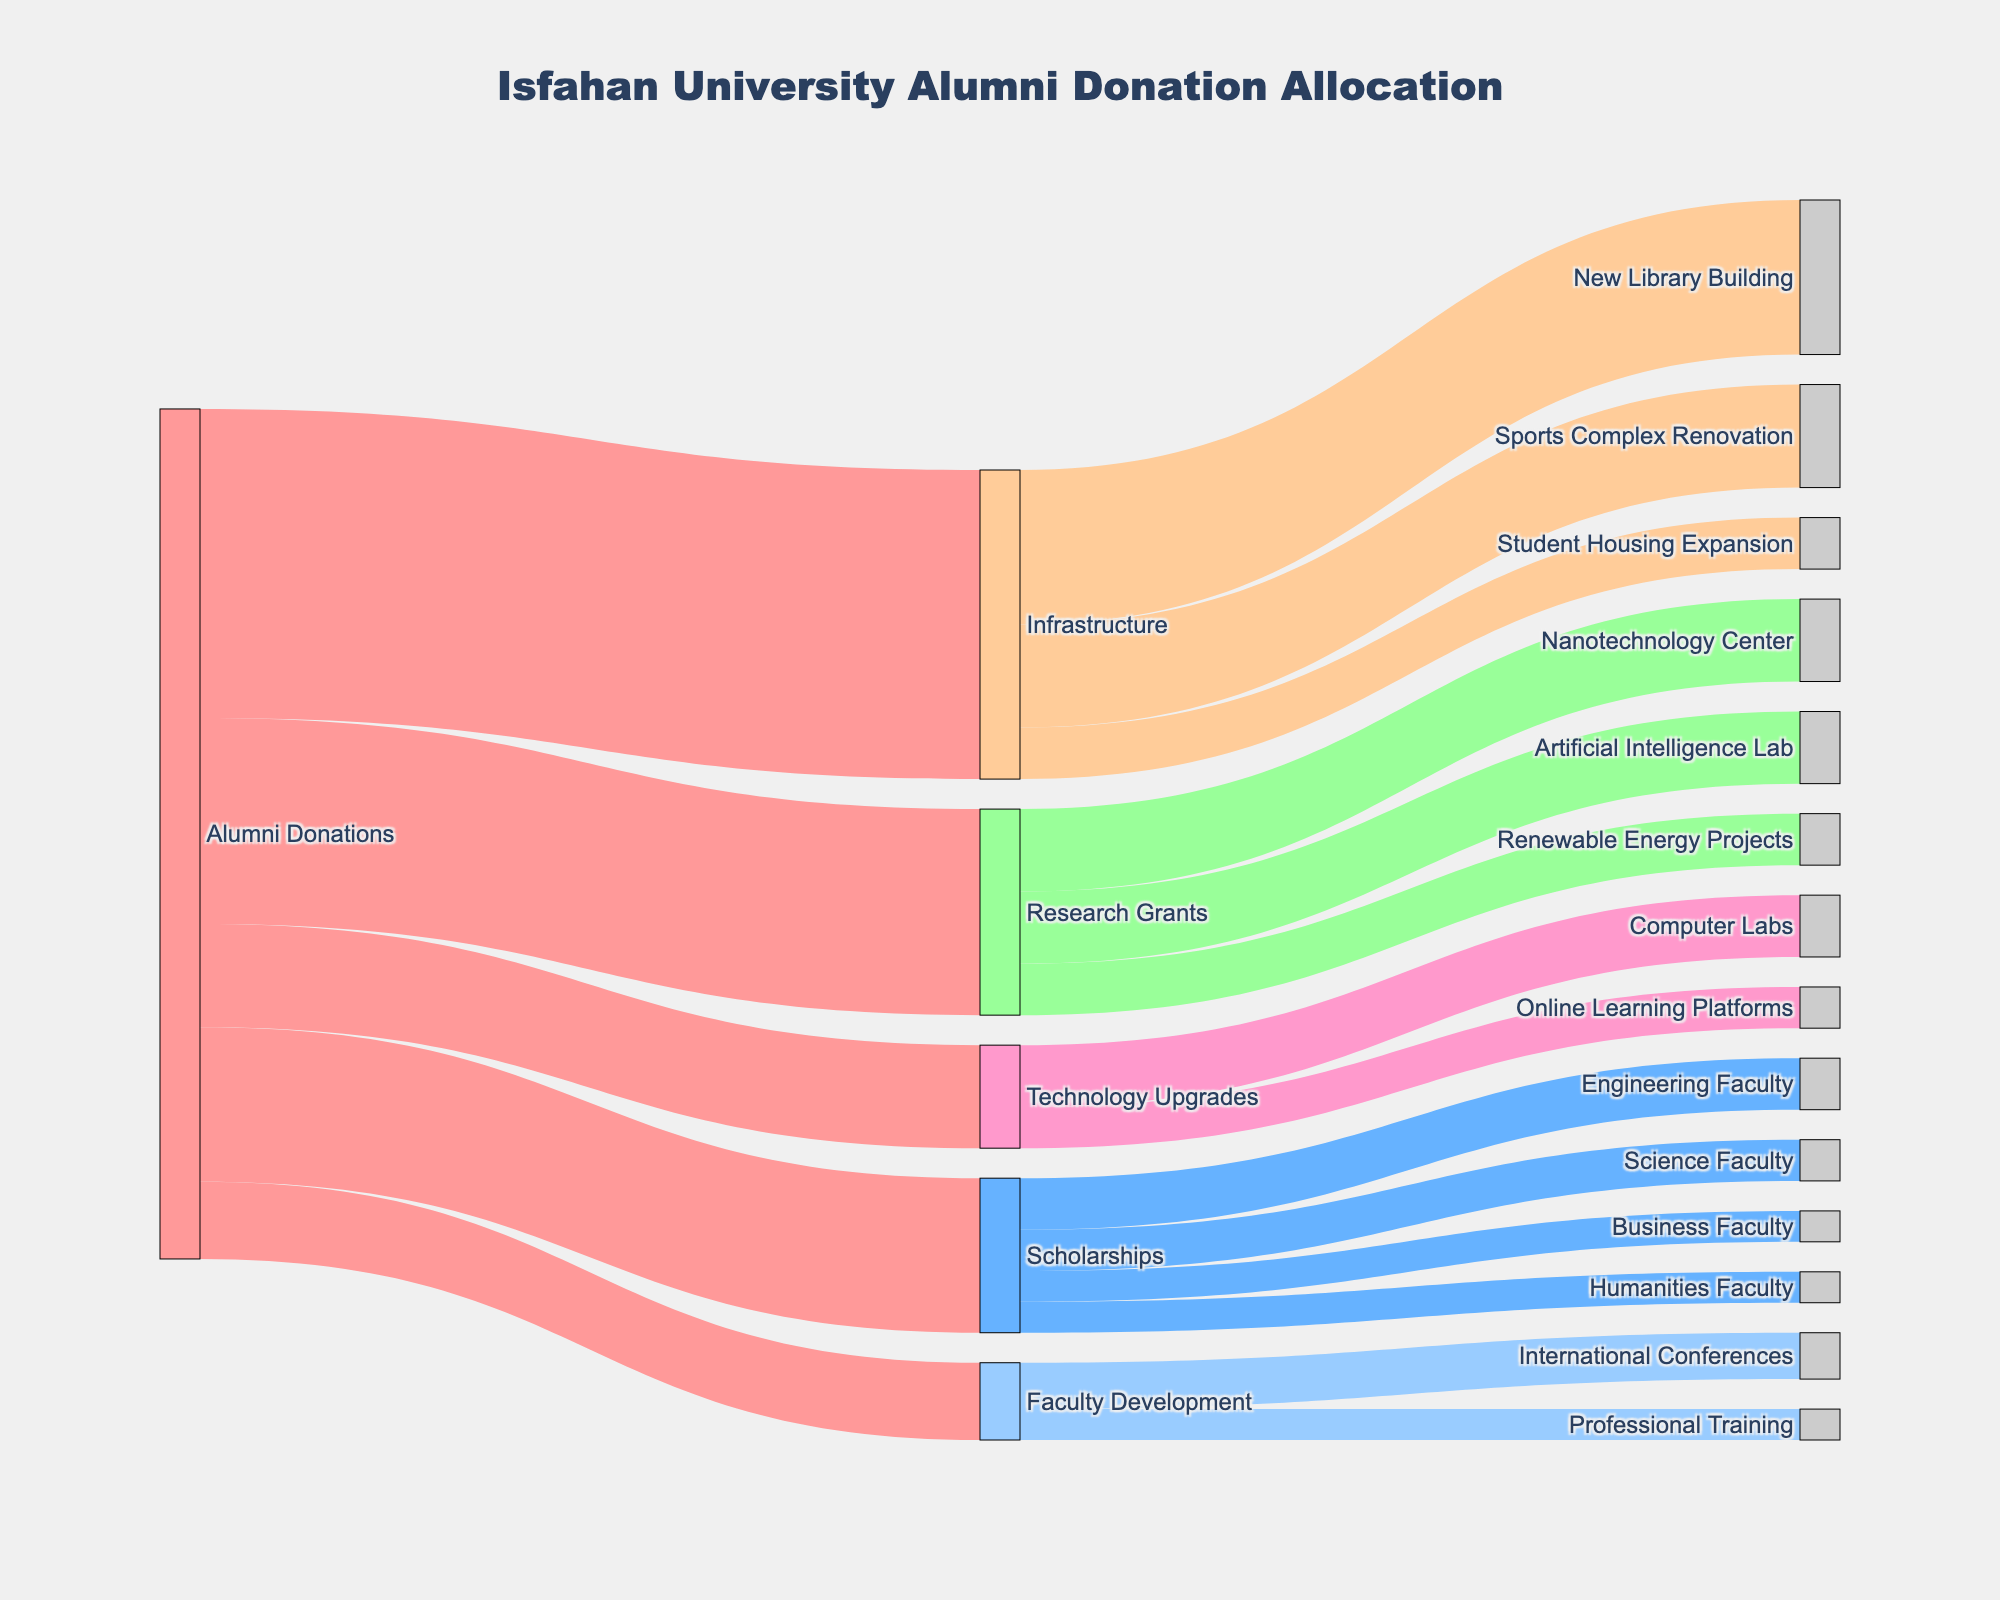What is the total amount donated by alumni? Sum the values of all donations: 150,000 (Scholarships) + 200,000 (Research Grants) + 300,000 (Infrastructure) + 100,000 (Technology Upgrades) + 75,000 (Faculty Development)
Answer: 825,000 Which project received the highest funding from alumni donations? The projects and their respective funds are: Scholarships (150,000), Research Grants (200,000), Infrastructure (300,000), Technology Upgrades (100,000), and Faculty Development (75,000). Compare these values.
Answer: Infrastructure How much funding did the Nanotechnology Center receive? Look at the flow from Research Grants to Nanotechnology Center.
Answer: 80,000 Which category under 'Scholarships' received the least funding? The categories and their funds under 'Scholarships' are: Engineering Faculty (50,000), Science Faculty (40,000), Humanities Faculty (30,000), Business Faculty (30,000). Compare these values.
Answer: Humanities Faculty & Business Faculty What is the total funding allocated to the 'Infrastructure' projects? Sum the values of Infrastructure projects: 150,000 (New Library Building) + 100,000 (Sports Complex Renovation) + 50,000 (Student Housing Expansion).
Answer: 300,000 How does the funding for Faculty Development compare to Technology Upgrades? Faculty Development received 75,000, while Technology Upgrades received 100,000. Compare these values directly.
Answer: Technology Upgrades received more What percentage of Scholarship funds were allocated to the Engineering Faculty? The total Scholarship funds equal 150,000, and Engineering Faculty received 50,000. Calculate the percentage: (50,000 / 150,000) * 100.
Answer: 33.33% Which two departments received funding under Technology Upgrades, and how much did each receive? Under Technology Upgrades, check the target departments and their respective funding. Computer Labs received 60,000, and Online Learning Platforms received 40,000.
Answer: Computer Labs 60,000, Online Learning Platforms 40,000 Compare the funding received by the Artificial Intelligence Lab and the Renewable Energy Projects under Research Grants. Artificial Intelligence Lab received 70,000, while Renewable Energy Projects received 50,000.
Answer: Artificial Intelligence Lab received more What is the combined total of donations allocated to Student Housing Expansion and Professional Training? Add the values: 50,000 (Student Housing Expansion) + 30,000 (Professional Training).
Answer: 80,000 